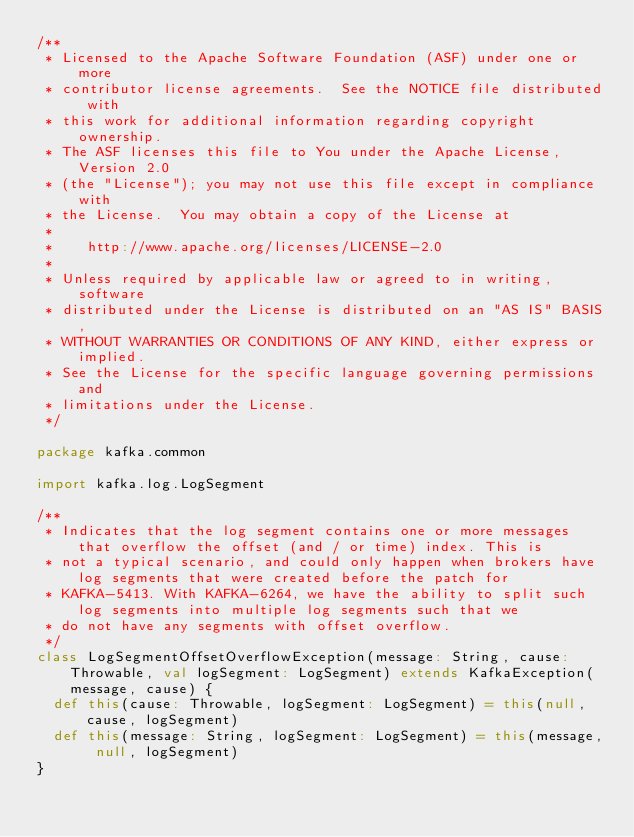<code> <loc_0><loc_0><loc_500><loc_500><_Scala_>/**
 * Licensed to the Apache Software Foundation (ASF) under one or more
 * contributor license agreements.  See the NOTICE file distributed with
 * this work for additional information regarding copyright ownership.
 * The ASF licenses this file to You under the Apache License, Version 2.0
 * (the "License"); you may not use this file except in compliance with
 * the License.  You may obtain a copy of the License at
 *
 *    http://www.apache.org/licenses/LICENSE-2.0
 *
 * Unless required by applicable law or agreed to in writing, software
 * distributed under the License is distributed on an "AS IS" BASIS,
 * WITHOUT WARRANTIES OR CONDITIONS OF ANY KIND, either express or implied.
 * See the License for the specific language governing permissions and
 * limitations under the License.
 */

package kafka.common

import kafka.log.LogSegment

/**
 * Indicates that the log segment contains one or more messages that overflow the offset (and / or time) index. This is
 * not a typical scenario, and could only happen when brokers have log segments that were created before the patch for
 * KAFKA-5413. With KAFKA-6264, we have the ability to split such log segments into multiple log segments such that we
 * do not have any segments with offset overflow.
 */
class LogSegmentOffsetOverflowException(message: String, cause: Throwable, val logSegment: LogSegment) extends KafkaException(message, cause) {
  def this(cause: Throwable, logSegment: LogSegment) = this(null, cause, logSegment)
  def this(message: String, logSegment: LogSegment) = this(message, null, logSegment)
}
</code> 